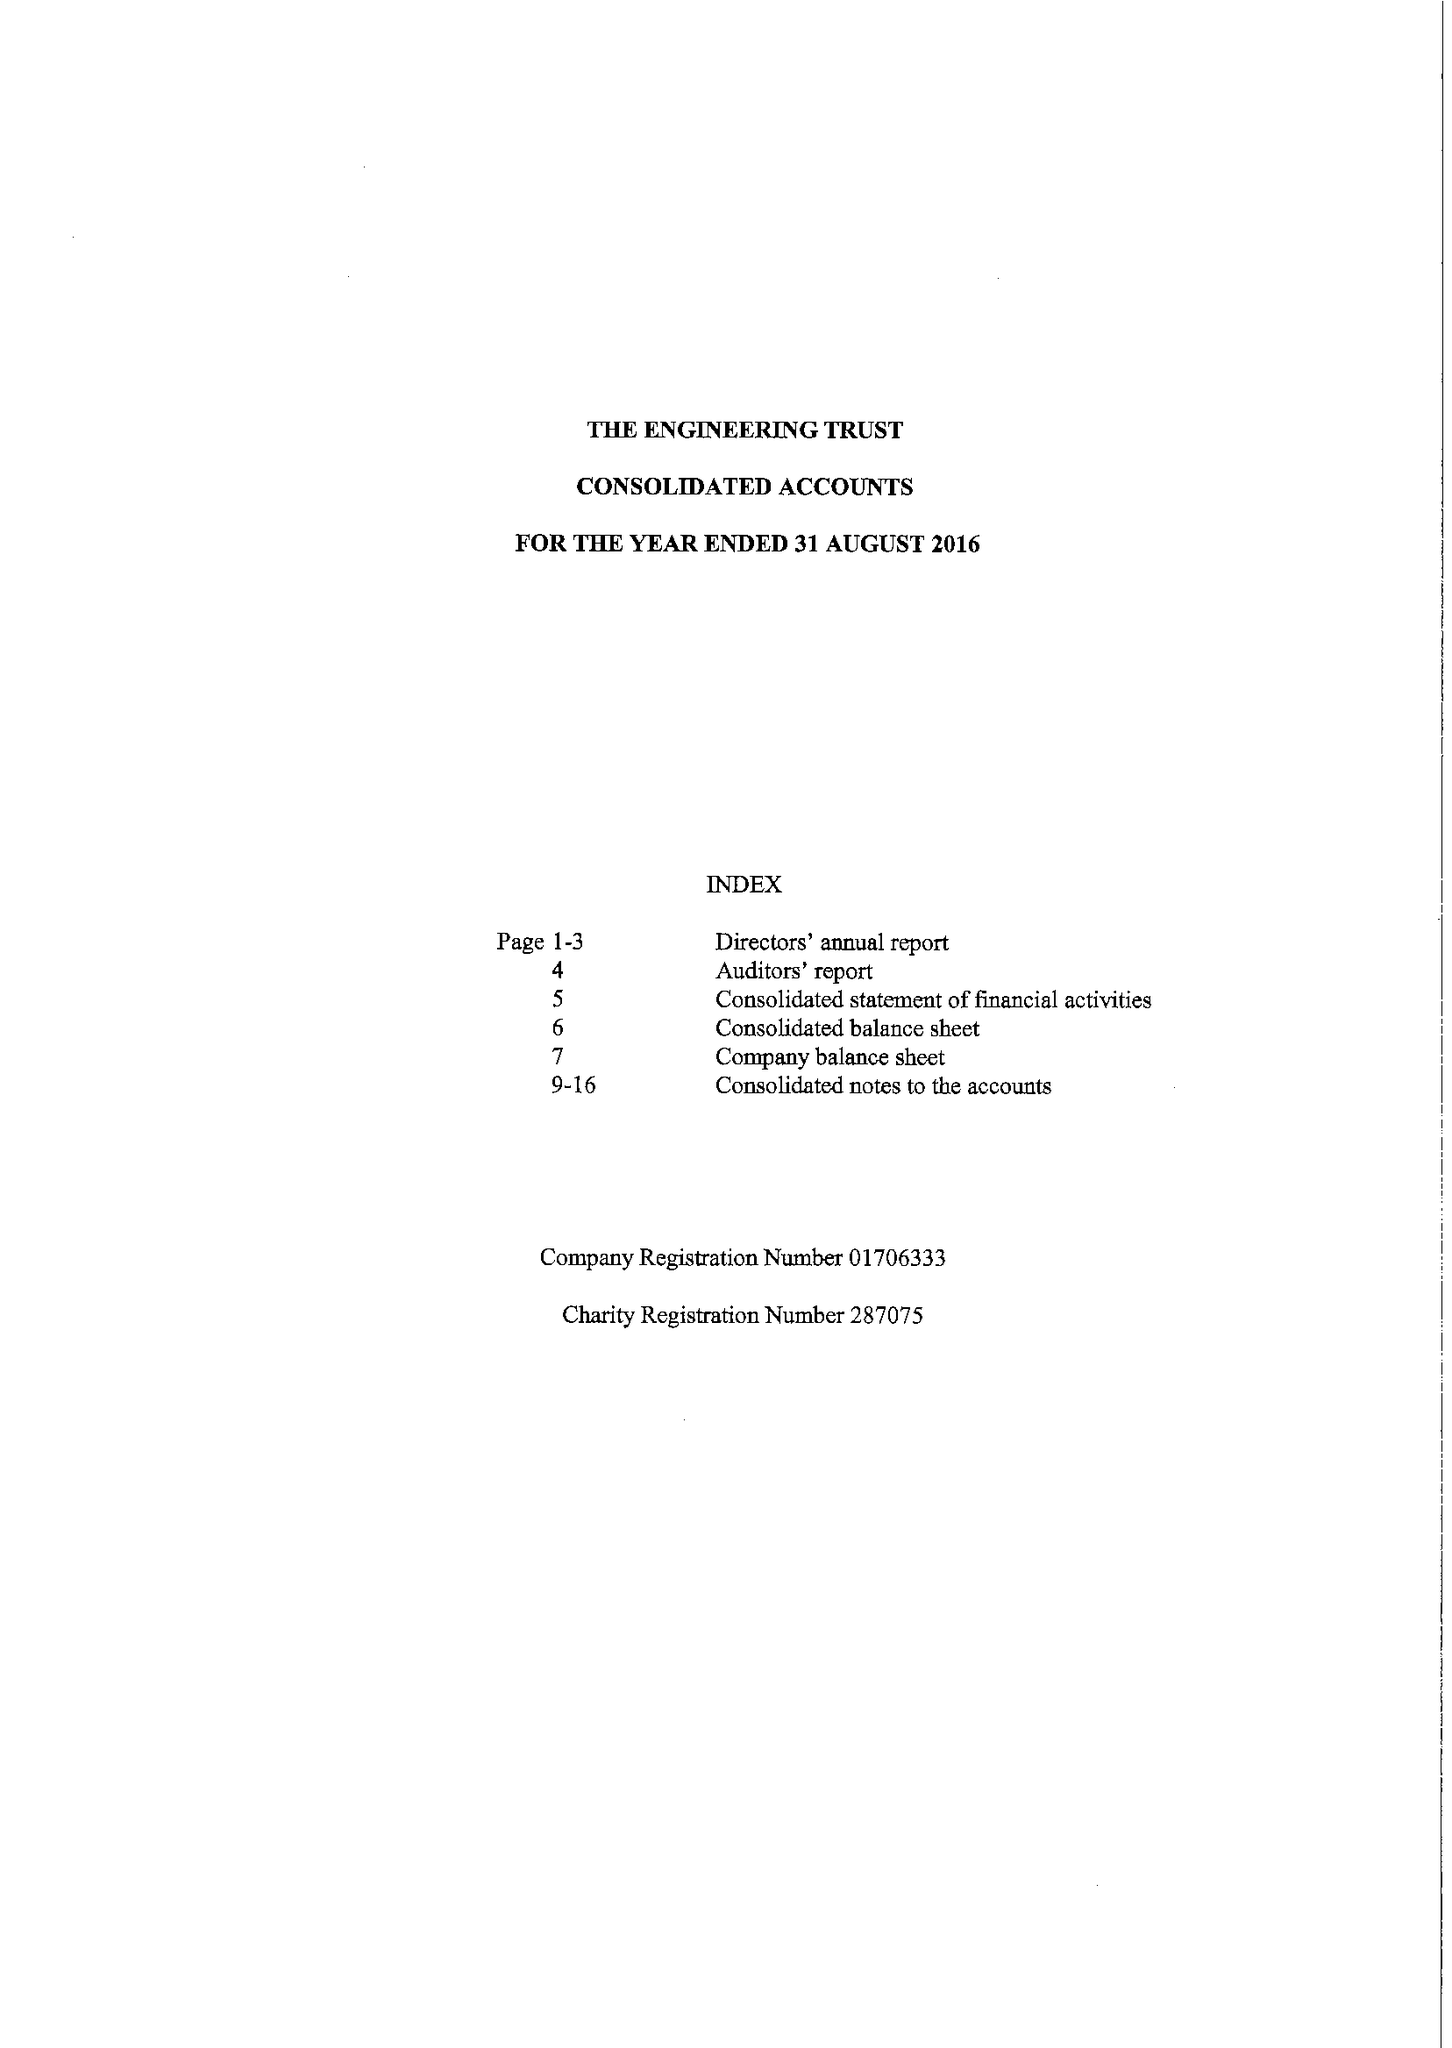What is the value for the address__post_town?
Answer the question using a single word or phrase. BICESTER 